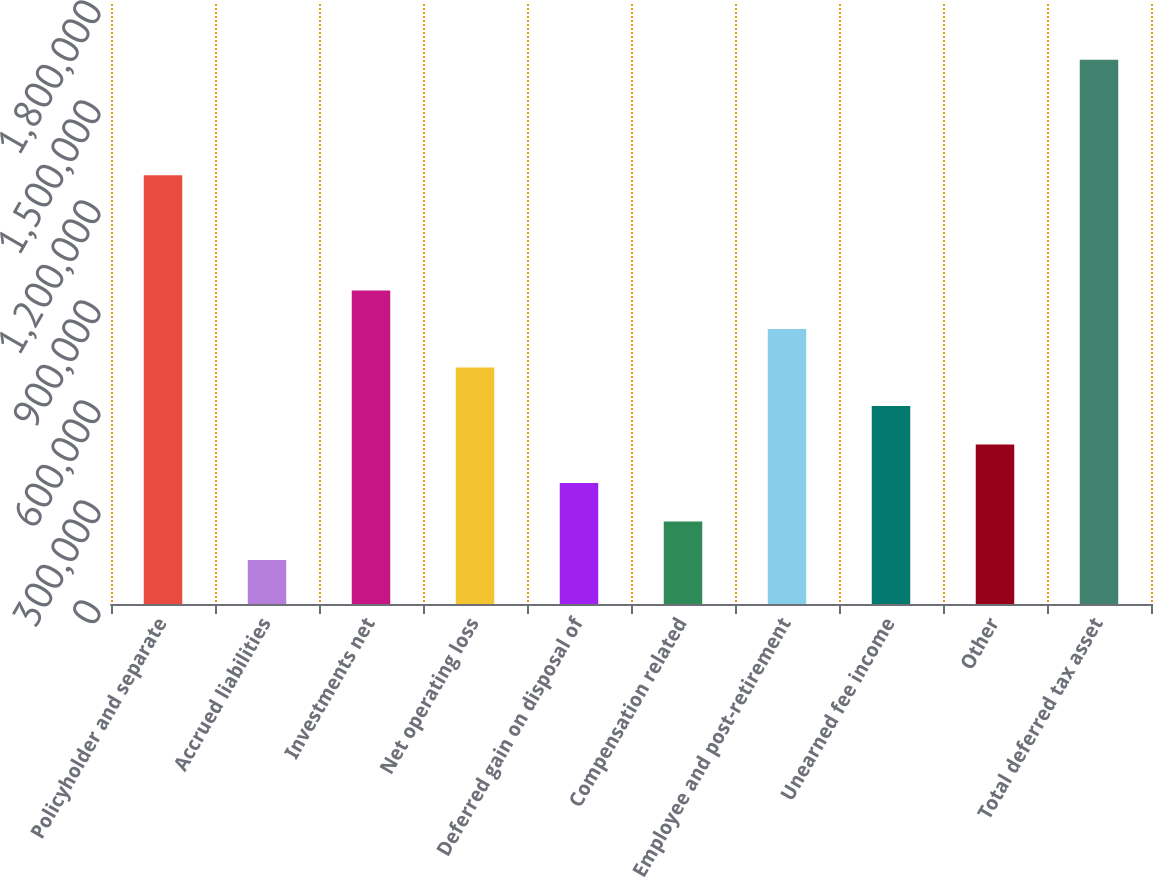Convert chart to OTSL. <chart><loc_0><loc_0><loc_500><loc_500><bar_chart><fcel>Policyholder and separate<fcel>Accrued liabilities<fcel>Investments net<fcel>Net operating loss<fcel>Deferred gain on disposal of<fcel>Compensation related<fcel>Employee and post-retirement<fcel>Unearned fee income<fcel>Other<fcel>Total deferred tax asset<nl><fcel>1.2866e+06<fcel>131940<fcel>940201<fcel>709269<fcel>362872<fcel>247406<fcel>824735<fcel>593804<fcel>478338<fcel>1.633e+06<nl></chart> 